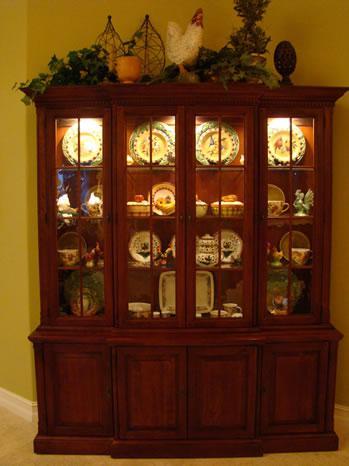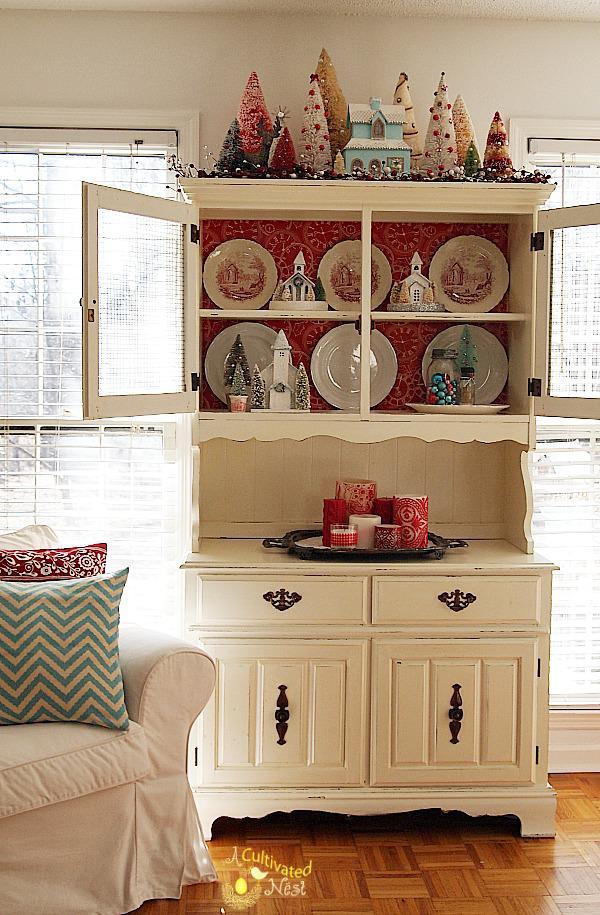The first image is the image on the left, the second image is the image on the right. For the images displayed, is the sentence "An image shows a white cabinet with feet and a scroll-curved bottom." factually correct? Answer yes or no. Yes. The first image is the image on the left, the second image is the image on the right. Examine the images to the left and right. Is the description "A wooden hutch with three glass doors in its upper section has a center section of drawers between two solid doors in the bottom section." accurate? Answer yes or no. No. The first image is the image on the left, the second image is the image on the right. Examine the images to the left and right. Is the description "One of the cabinets against the wall is white." accurate? Answer yes or no. Yes. The first image is the image on the left, the second image is the image on the right. Assess this claim about the two images: "The cabinet on the left is rich brown wood, and the cabinet on the right is white, with scrollwork and legs on the base.". Correct or not? Answer yes or no. Yes. 